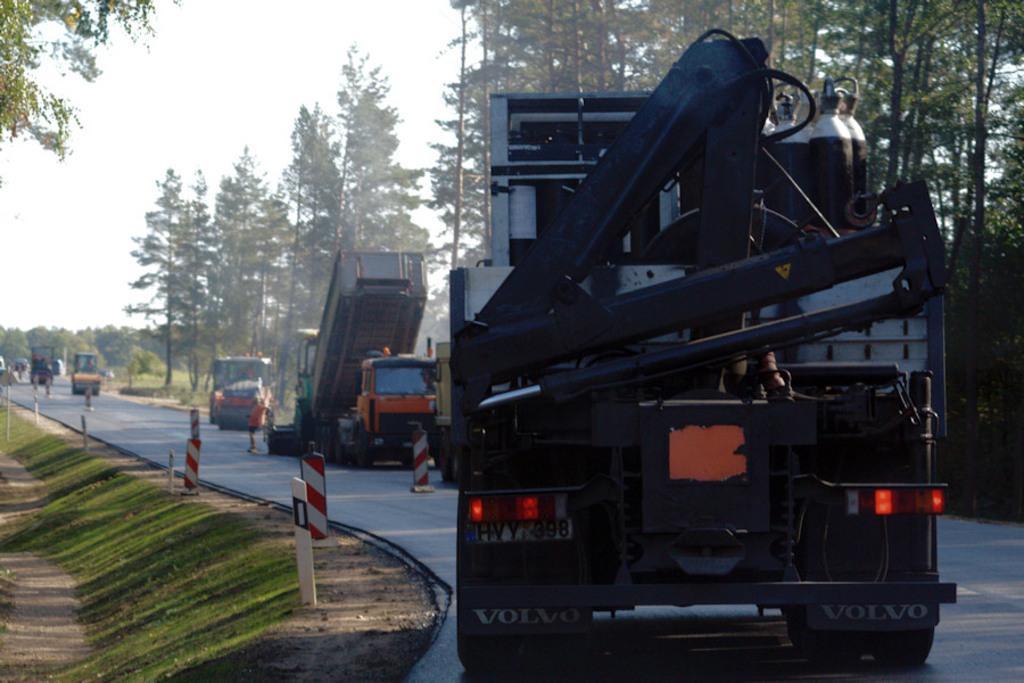In one or two sentences, can you explain what this image depicts? In this image I can see the road, few vehicles on the road, few traffic poles, some grass on the ground and few trees which are green in color. In the background I can see the sky. 